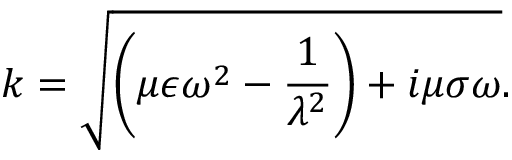Convert formula to latex. <formula><loc_0><loc_0><loc_500><loc_500>k = \sqrt { \left ( \mu \epsilon \omega ^ { 2 } - \frac { 1 } { \lambda ^ { 2 } } \right ) + i \mu \sigma \omega } .</formula> 